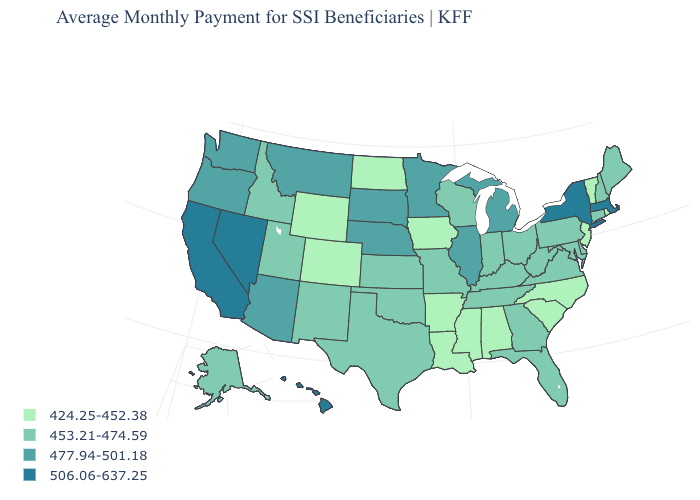Does the map have missing data?
Answer briefly. No. Among the states that border Utah , does Nevada have the highest value?
Short answer required. Yes. What is the lowest value in states that border Nevada?
Quick response, please. 453.21-474.59. Name the states that have a value in the range 424.25-452.38?
Give a very brief answer. Alabama, Arkansas, Colorado, Iowa, Louisiana, Mississippi, New Jersey, North Carolina, North Dakota, Rhode Island, South Carolina, Vermont, Wyoming. Which states have the lowest value in the MidWest?
Give a very brief answer. Iowa, North Dakota. Does New Jersey have the highest value in the Northeast?
Answer briefly. No. Which states have the highest value in the USA?
Keep it brief. California, Hawaii, Massachusetts, Nevada, New York. Does Montana have the lowest value in the USA?
Concise answer only. No. What is the value of Mississippi?
Be succinct. 424.25-452.38. Which states have the lowest value in the West?
Short answer required. Colorado, Wyoming. Does the first symbol in the legend represent the smallest category?
Write a very short answer. Yes. What is the value of Pennsylvania?
Quick response, please. 453.21-474.59. Which states have the lowest value in the South?
Give a very brief answer. Alabama, Arkansas, Louisiana, Mississippi, North Carolina, South Carolina. What is the value of West Virginia?
Keep it brief. 453.21-474.59. Name the states that have a value in the range 477.94-501.18?
Answer briefly. Arizona, Illinois, Michigan, Minnesota, Montana, Nebraska, Oregon, South Dakota, Washington. 